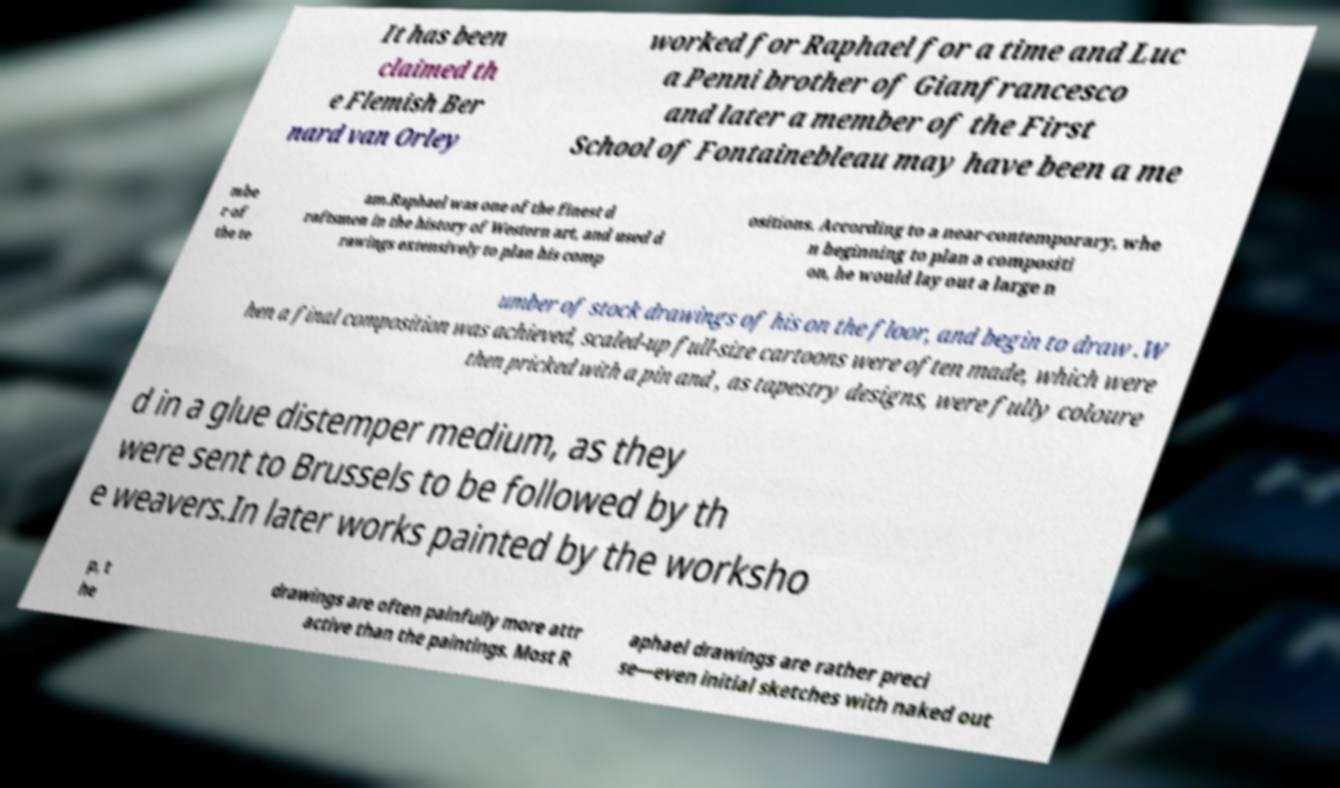I need the written content from this picture converted into text. Can you do that? It has been claimed th e Flemish Ber nard van Orley worked for Raphael for a time and Luc a Penni brother of Gianfrancesco and later a member of the First School of Fontainebleau may have been a me mbe r of the te am.Raphael was one of the finest d raftsmen in the history of Western art, and used d rawings extensively to plan his comp ositions. According to a near-contemporary, whe n beginning to plan a compositi on, he would lay out a large n umber of stock drawings of his on the floor, and begin to draw .W hen a final composition was achieved, scaled-up full-size cartoons were often made, which were then pricked with a pin and , as tapestry designs, were fully coloure d in a glue distemper medium, as they were sent to Brussels to be followed by th e weavers.In later works painted by the worksho p, t he drawings are often painfully more attr active than the paintings. Most R aphael drawings are rather preci se—even initial sketches with naked out 